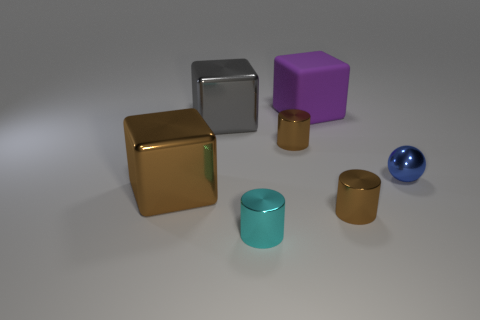Subtract all cyan blocks. How many brown cylinders are left? 2 Subtract all brown metal cylinders. How many cylinders are left? 1 Add 1 tiny objects. How many objects exist? 8 Subtract all cylinders. How many objects are left? 4 Subtract all green cylinders. Subtract all green balls. How many cylinders are left? 3 Subtract all brown shiny blocks. Subtract all blue metal objects. How many objects are left? 5 Add 7 metal cylinders. How many metal cylinders are left? 10 Add 7 big brown blocks. How many big brown blocks exist? 8 Subtract 0 red spheres. How many objects are left? 7 